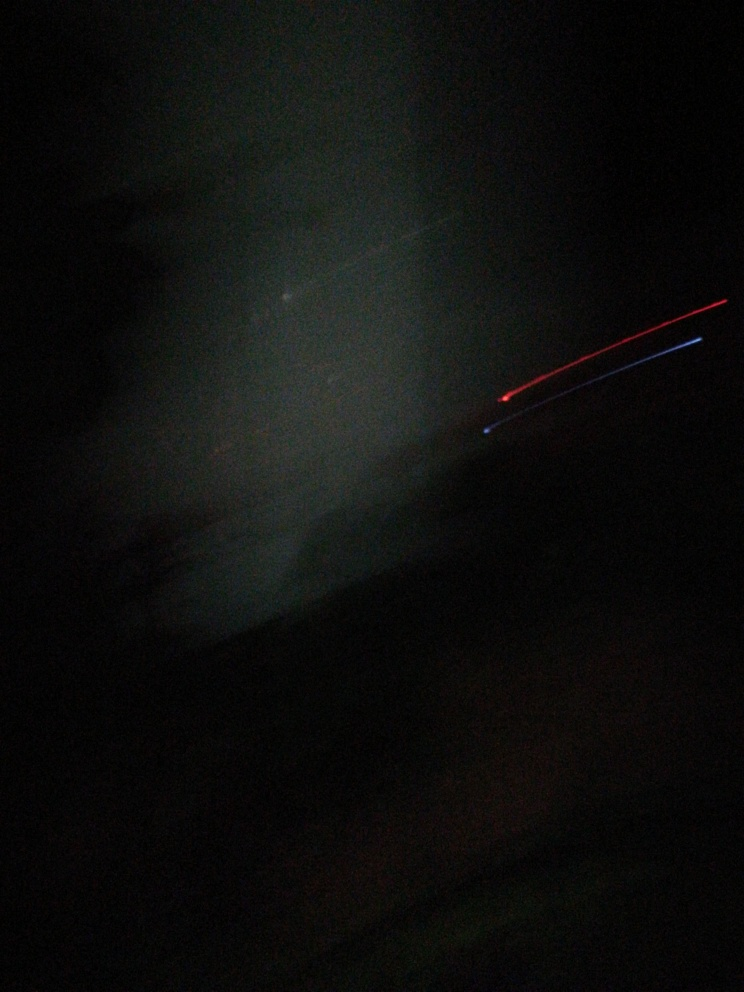Can you suggest how to improve this photo's visibility? To improve this photo's visibility, I'd recommend adjusting the brightness and contrast to bring out hidden details. Using photo editing software to increase the exposure might also help, as well as applying some noise reduction techniques if the image is grainy. 